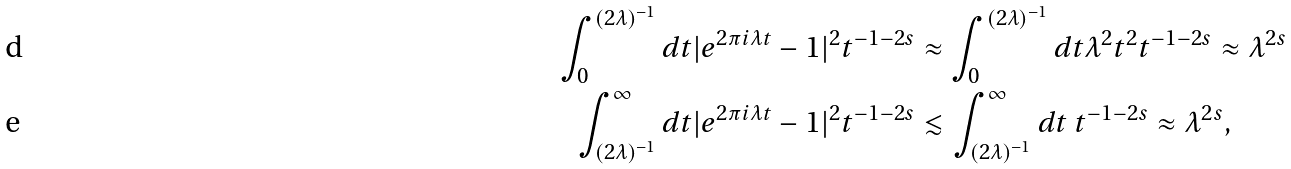<formula> <loc_0><loc_0><loc_500><loc_500>\int _ { 0 } ^ { ( 2 \lambda ) ^ { - 1 } } d t | e ^ { 2 \pi i \lambda t } - 1 | ^ { 2 } t ^ { - 1 - 2 s } & \approx \int _ { 0 } ^ { ( 2 \lambda ) ^ { - 1 } } d t \lambda ^ { 2 } t ^ { 2 } t ^ { - 1 - 2 s } \approx \lambda ^ { 2 s } \\ \int _ { ( 2 \lambda ) ^ { - 1 } } ^ { \infty } d t | e ^ { 2 \pi i \lambda t } - 1 | ^ { 2 } t ^ { - 1 - 2 s } & \lesssim \int _ { ( 2 \lambda ) ^ { - 1 } } ^ { \infty } d t \ t ^ { - 1 - 2 s } \approx \lambda ^ { 2 s } ,</formula> 